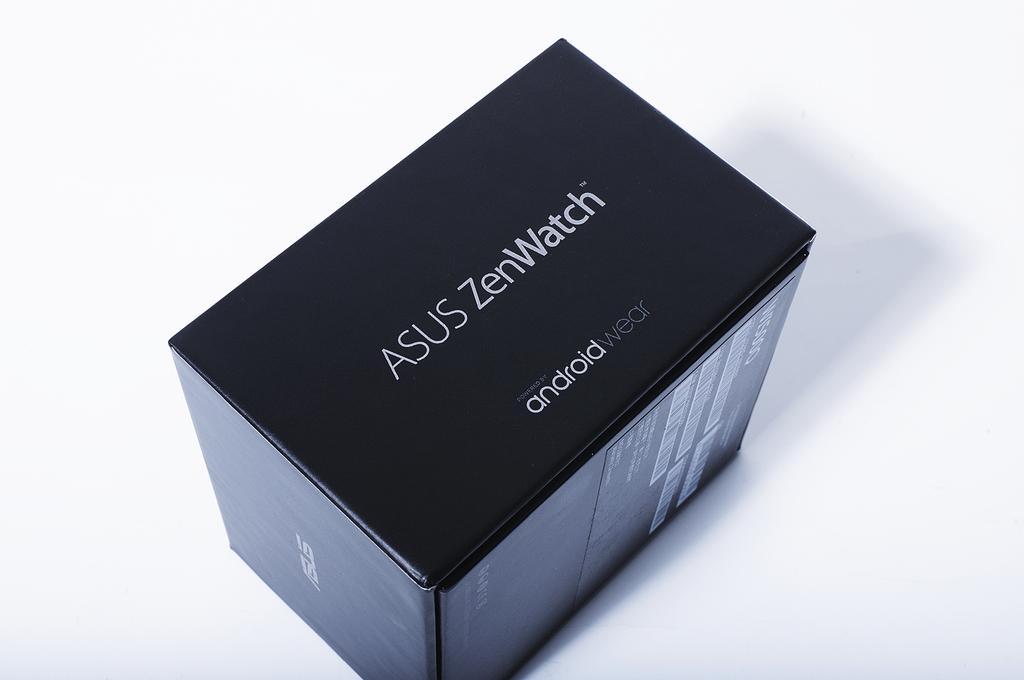What ios is this watch?
Ensure brevity in your answer.  Android. What brand makes this watch?
Ensure brevity in your answer.  Asus. 